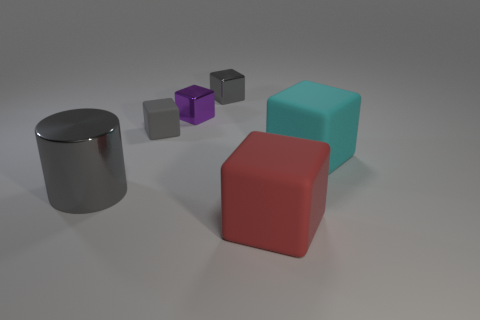What kind of lighting appears to be used in this scene? The scene is lit with soft, diffused lighting, as evidenced by the gentle shadows beneath the objects and the lack of sharp contrasts. The light source direction is not clear, but it seems to be above and possibly slightly to the front of the objects, casting soft-edged shadows toward the back. 